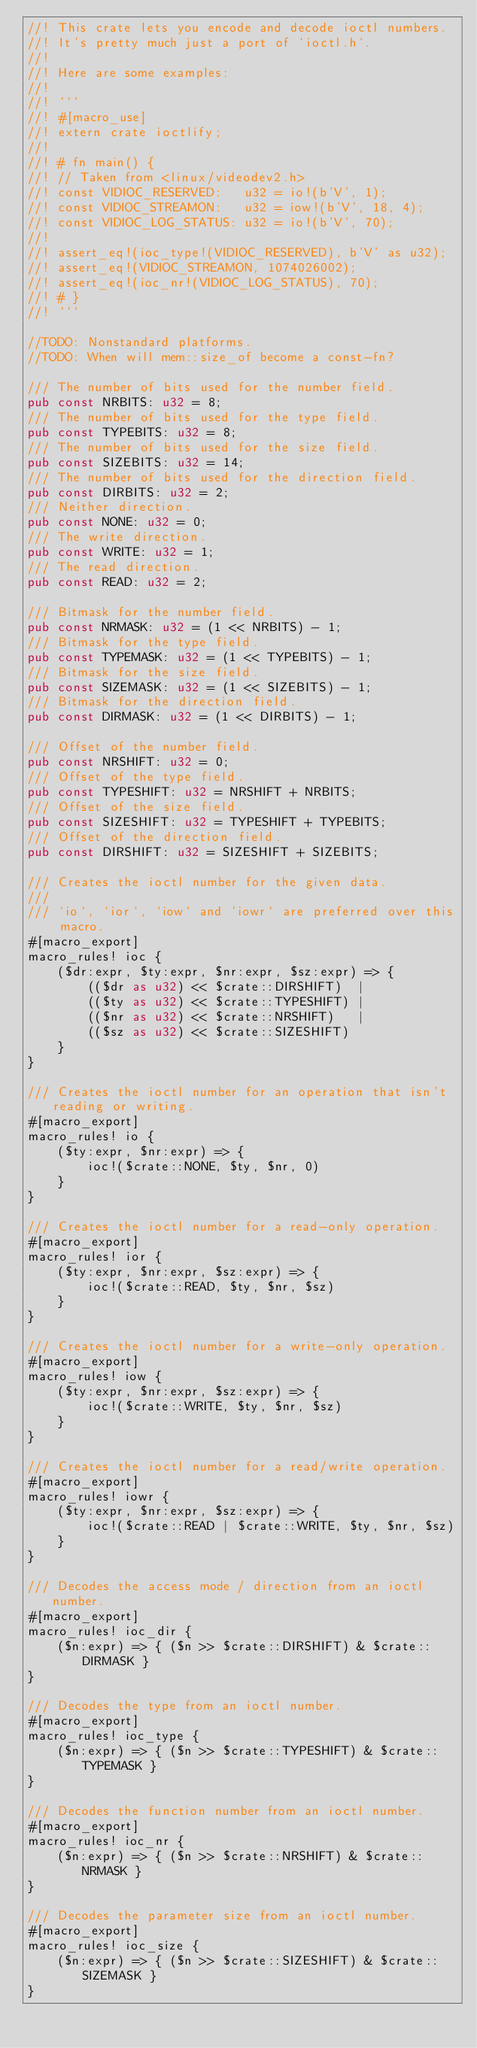<code> <loc_0><loc_0><loc_500><loc_500><_Rust_>//! This crate lets you encode and decode ioctl numbers.
//! It's pretty much just a port of `ioctl.h`.
//!
//! Here are some examples:
//!
//! ```
//! #[macro_use]
//! extern crate ioctlify;
//!
//! # fn main() {
//! // Taken from <linux/videodev2.h>
//! const VIDIOC_RESERVED:   u32 = io!(b'V', 1);
//! const VIDIOC_STREAMON:   u32 = iow!(b'V', 18, 4);
//! const VIDIOC_LOG_STATUS: u32 = io!(b'V', 70);
//!
//! assert_eq!(ioc_type!(VIDIOC_RESERVED), b'V' as u32);
//! assert_eq!(VIDIOC_STREAMON, 1074026002);
//! assert_eq!(ioc_nr!(VIDIOC_LOG_STATUS), 70);
//! # }
//! ```

//TODO: Nonstandard platforms.
//TODO: When will mem::size_of become a const-fn?

/// The number of bits used for the number field.
pub const NRBITS: u32 = 8;
/// The number of bits used for the type field.
pub const TYPEBITS: u32 = 8;
/// The number of bits used for the size field.
pub const SIZEBITS: u32 = 14;
/// The number of bits used for the direction field.
pub const DIRBITS: u32 = 2;
/// Neither direction.
pub const NONE: u32 = 0;
/// The write direction.
pub const WRITE: u32 = 1;
/// The read direction.
pub const READ: u32 = 2;

/// Bitmask for the number field.
pub const NRMASK: u32 = (1 << NRBITS) - 1;
/// Bitmask for the type field.
pub const TYPEMASK: u32 = (1 << TYPEBITS) - 1;
/// Bitmask for the size field.
pub const SIZEMASK: u32 = (1 << SIZEBITS) - 1;
/// Bitmask for the direction field.
pub const DIRMASK: u32 = (1 << DIRBITS) - 1;

/// Offset of the number field.
pub const NRSHIFT: u32 = 0;
/// Offset of the type field.
pub const TYPESHIFT: u32 = NRSHIFT + NRBITS;
/// Offset of the size field.
pub const SIZESHIFT: u32 = TYPESHIFT + TYPEBITS;
/// Offset of the direction field.
pub const DIRSHIFT: u32 = SIZESHIFT + SIZEBITS;

/// Creates the ioctl number for the given data.
///
/// `io`, `ior`, `iow` and `iowr` are preferred over this macro.
#[macro_export]
macro_rules! ioc {
    ($dr:expr, $ty:expr, $nr:expr, $sz:expr) => {
        (($dr as u32) << $crate::DIRSHIFT)  |
        (($ty as u32) << $crate::TYPESHIFT) |
        (($nr as u32) << $crate::NRSHIFT)   |
        (($sz as u32) << $crate::SIZESHIFT)
    }
}

/// Creates the ioctl number for an operation that isn't reading or writing.
#[macro_export]
macro_rules! io {
    ($ty:expr, $nr:expr) => {
        ioc!($crate::NONE, $ty, $nr, 0)
    }
}

/// Creates the ioctl number for a read-only operation.
#[macro_export]
macro_rules! ior {
    ($ty:expr, $nr:expr, $sz:expr) => {
        ioc!($crate::READ, $ty, $nr, $sz)
    }
}

/// Creates the ioctl number for a write-only operation.
#[macro_export]
macro_rules! iow {
    ($ty:expr, $nr:expr, $sz:expr) => {
        ioc!($crate::WRITE, $ty, $nr, $sz)
    }
}

/// Creates the ioctl number for a read/write operation.
#[macro_export]
macro_rules! iowr {
    ($ty:expr, $nr:expr, $sz:expr) => {
        ioc!($crate::READ | $crate::WRITE, $ty, $nr, $sz)
    }
}

/// Decodes the access mode / direction from an ioctl number.
#[macro_export]
macro_rules! ioc_dir {
    ($n:expr) => { ($n >> $crate::DIRSHIFT) & $crate::DIRMASK }
}

/// Decodes the type from an ioctl number.
#[macro_export]
macro_rules! ioc_type {
    ($n:expr) => { ($n >> $crate::TYPESHIFT) & $crate::TYPEMASK }
}

/// Decodes the function number from an ioctl number.
#[macro_export]
macro_rules! ioc_nr {
    ($n:expr) => { ($n >> $crate::NRSHIFT) & $crate::NRMASK }
}

/// Decodes the parameter size from an ioctl number.
#[macro_export]
macro_rules! ioc_size {
    ($n:expr) => { ($n >> $crate::SIZESHIFT) & $crate::SIZEMASK }
}

</code> 